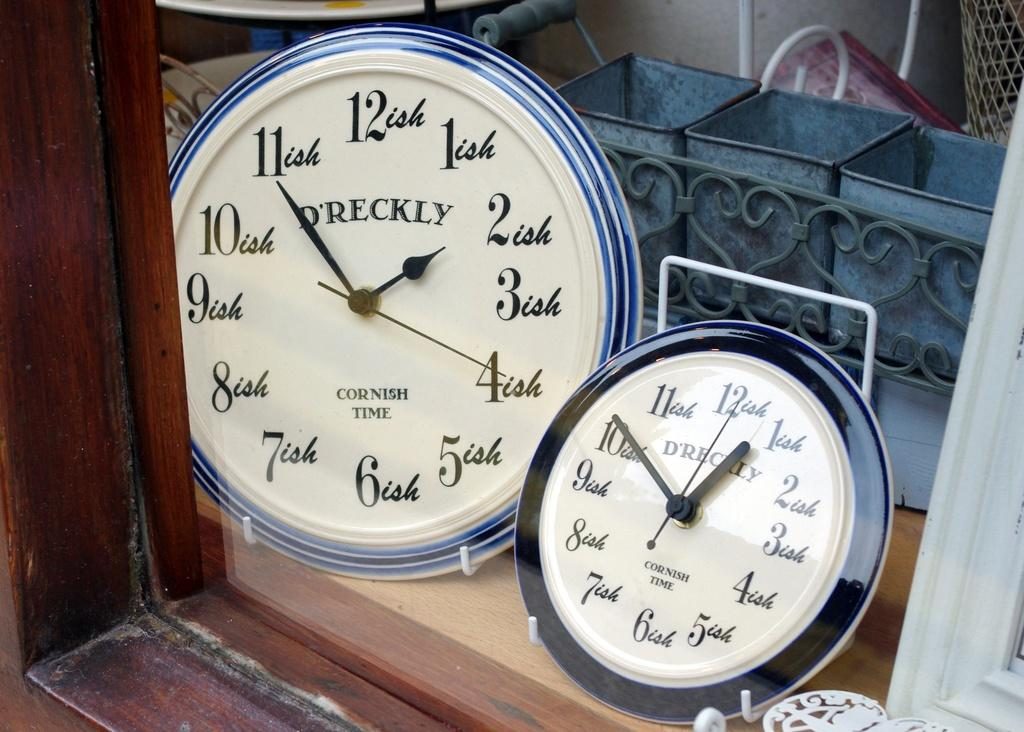<image>
Create a compact narrative representing the image presented. Two clocks next to one another with one saying CORNISH TIME. 